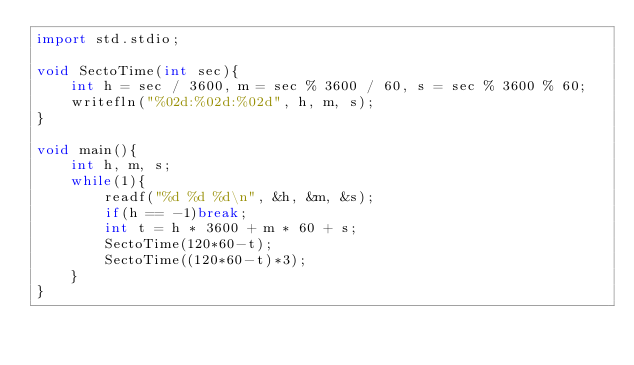Convert code to text. <code><loc_0><loc_0><loc_500><loc_500><_D_>import std.stdio;

void SectoTime(int sec){
	int h = sec / 3600, m = sec % 3600 / 60, s = sec % 3600 % 60;
	writefln("%02d:%02d:%02d", h, m, s);
}

void main(){
	int h, m, s;
	while(1){
		readf("%d %d %d\n", &h, &m, &s);
		if(h == -1)break;
		int t = h * 3600 + m * 60 + s;
		SectoTime(120*60-t);
		SectoTime((120*60-t)*3);
	}
}</code> 